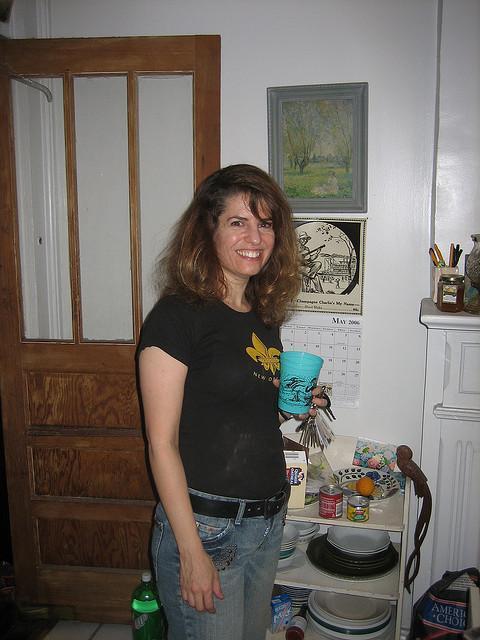How many black umbrellas are on the walkway?
Give a very brief answer. 0. 